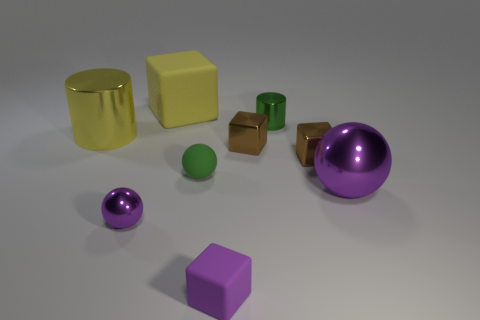Add 1 large red balls. How many objects exist? 10 Subtract all blocks. How many objects are left? 5 Add 6 big yellow cylinders. How many big yellow cylinders exist? 7 Subtract 0 gray cylinders. How many objects are left? 9 Subtract all purple objects. Subtract all big yellow matte objects. How many objects are left? 5 Add 6 purple blocks. How many purple blocks are left? 7 